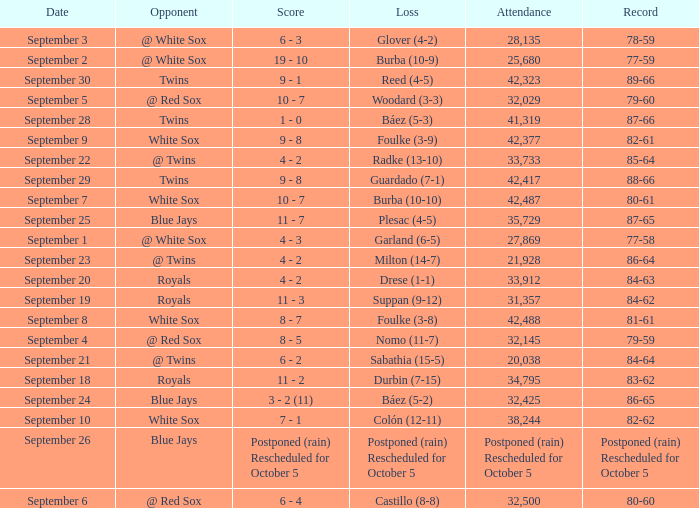What is the score of the game that holds a record of 80-61? 10 - 7. 